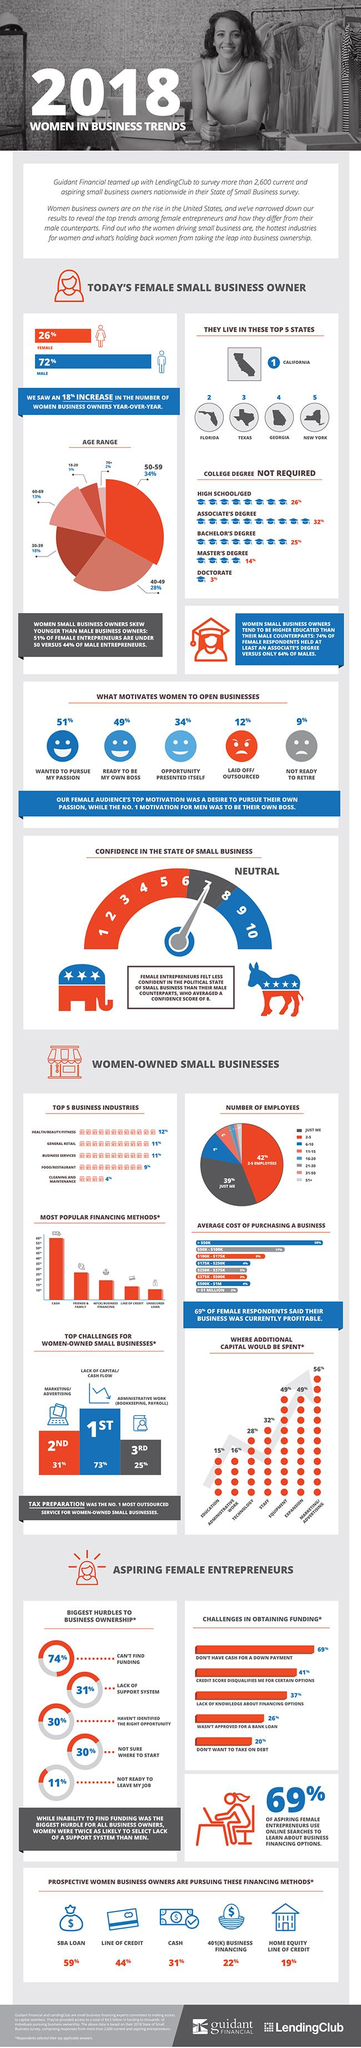Outline some significant characteristics in this image. A significant challenge faced by 31% of women-owned small businesses is marketing and advertising. Studies show that 73% of women-owned small businesses face a significant challenge in securing adequate funding, leading to cash flow issues and limiting their ability to grow and succeed. According to the survey, 12% of women started a business due to being laid off from their previous job. According to the survey, 51% of women have started their own business to pursue their passion. 